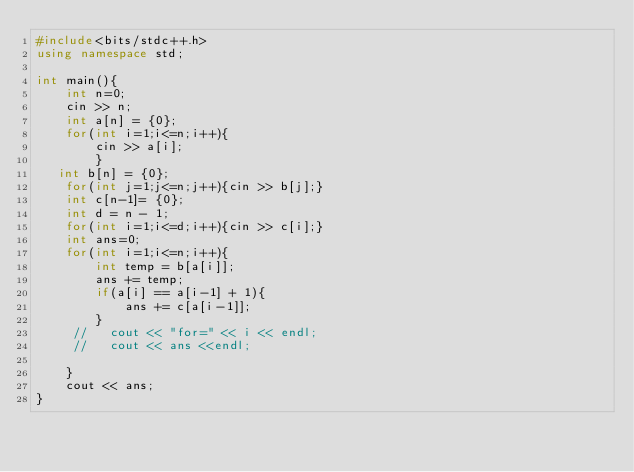Convert code to text. <code><loc_0><loc_0><loc_500><loc_500><_C++_>#include<bits/stdc++.h>
using namespace std;

int main(){
    int n=0;
    cin >> n;
    int a[n] = {0};
    for(int i=1;i<=n;i++){
        cin >> a[i];
        }
   int b[n] = {0};
    for(int j=1;j<=n;j++){cin >> b[j];}
    int c[n-1]= {0};
    int d = n - 1;
    for(int i=1;i<=d;i++){cin >> c[i];}
    int ans=0;
    for(int i=1;i<=n;i++){
        int temp = b[a[i]];
        ans += temp;       
        if(a[i] == a[i-1] + 1){
            ans += c[a[i-1]];
        }
     //   cout << "for=" << i << endl;
     //   cout << ans <<endl;
        
    }
    cout << ans;
}</code> 